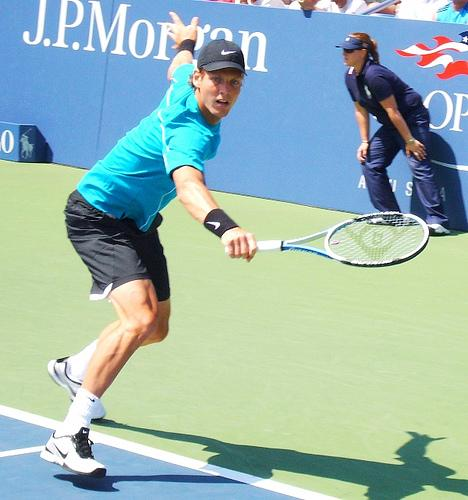What type of stroke is being used? Please explain your reasoning. forehand. His front hand is extended. 